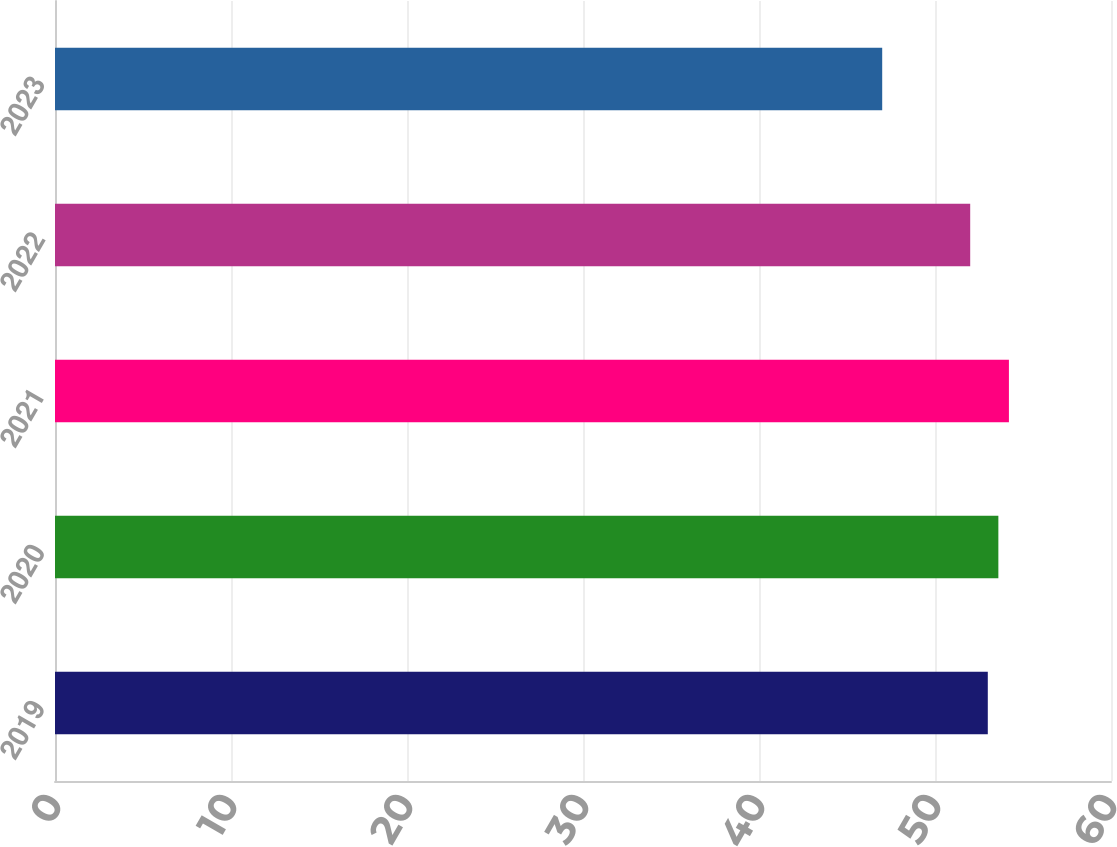Convert chart to OTSL. <chart><loc_0><loc_0><loc_500><loc_500><bar_chart><fcel>2019<fcel>2020<fcel>2021<fcel>2022<fcel>2023<nl><fcel>53<fcel>53.6<fcel>54.2<fcel>52<fcel>47<nl></chart> 